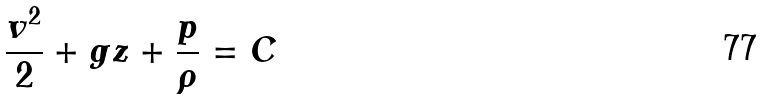<formula> <loc_0><loc_0><loc_500><loc_500>\frac { v ^ { 2 } } { 2 } + g z + \frac { p } { \rho } = C</formula> 